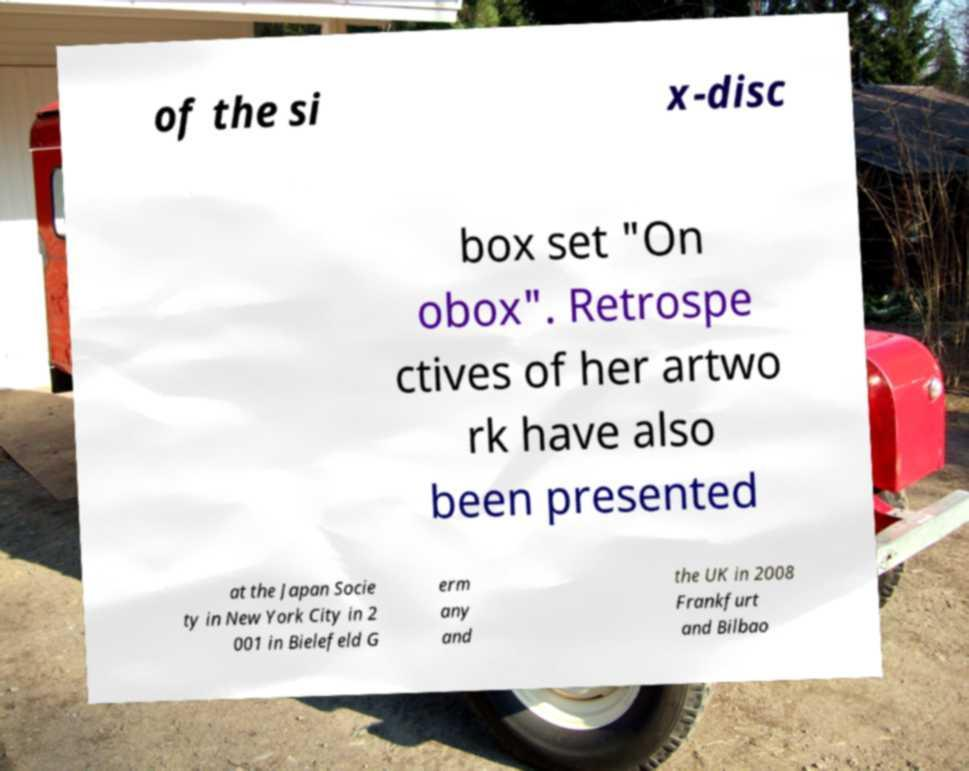Please identify and transcribe the text found in this image. of the si x-disc box set "On obox". Retrospe ctives of her artwo rk have also been presented at the Japan Socie ty in New York City in 2 001 in Bielefeld G erm any and the UK in 2008 Frankfurt and Bilbao 